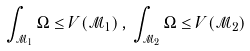<formula> <loc_0><loc_0><loc_500><loc_500>\int _ { \mathcal { M } _ { 1 } } \Omega \leq V ( \mathcal { M } _ { 1 } ) \, , \, \int _ { \mathcal { M } _ { 2 } } \Omega \leq V ( \mathcal { M } _ { 2 } )</formula> 